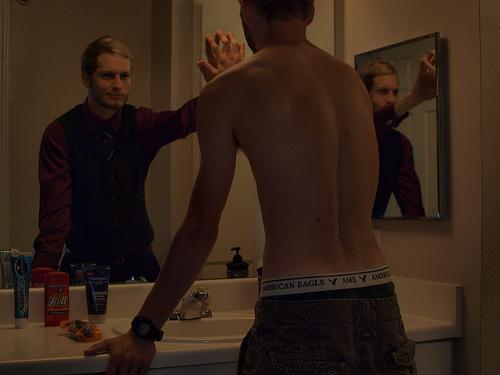How many people are not wearing a shirt?
Give a very brief answer. 1. 